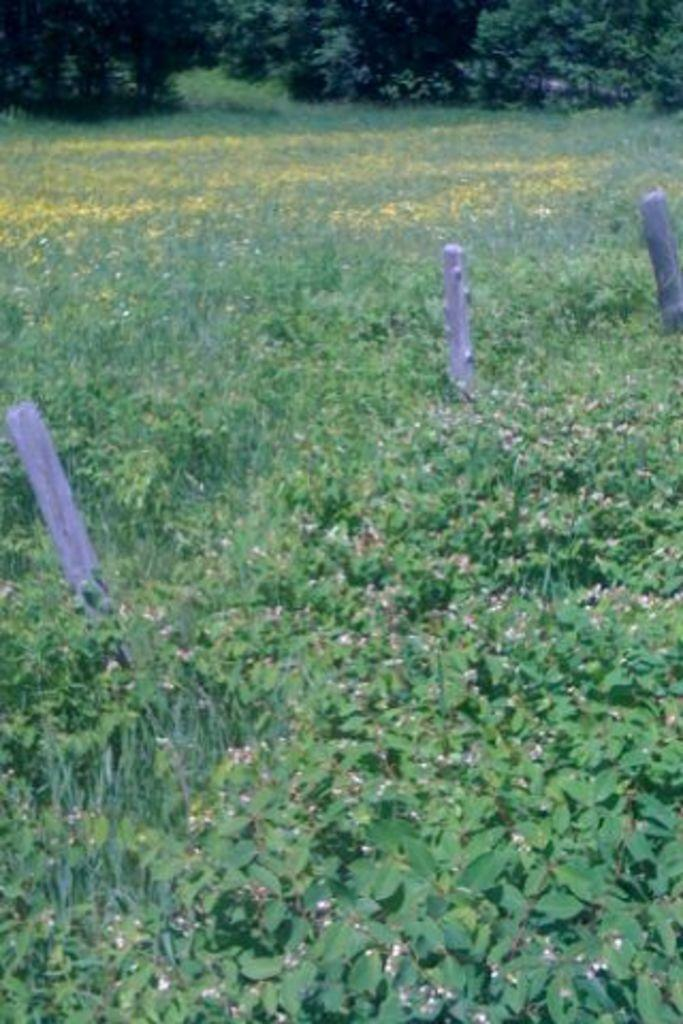What type of plants can be seen in the image? There is a group of plants in the image. What else is present on the ground in the image? There are poles on the ground in the image. What can be seen in the background of the image? There are several trees in the background of the image. What is your dad doing in the image? There is no person, including a dad, present in the image. How many worms can be seen crawling on the plants in the image? There are no worms visible in the image; it only features plants, poles, and trees. 